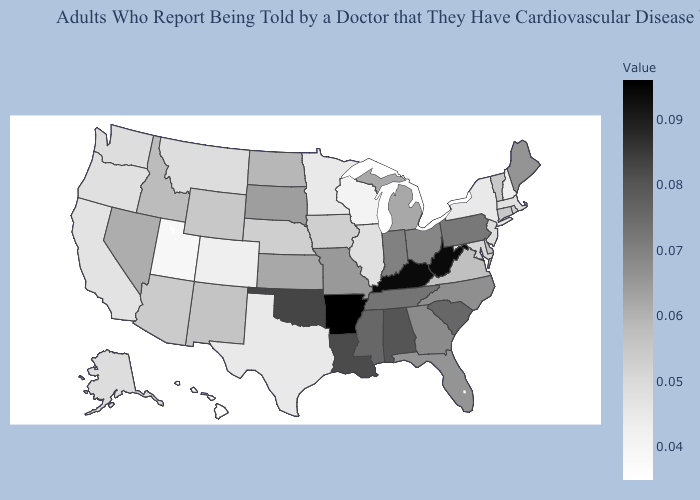Does Hawaii have the lowest value in the USA?
Answer briefly. Yes. Which states have the highest value in the USA?
Quick response, please. Arkansas. Does Washington have a lower value than Louisiana?
Quick response, please. Yes. 